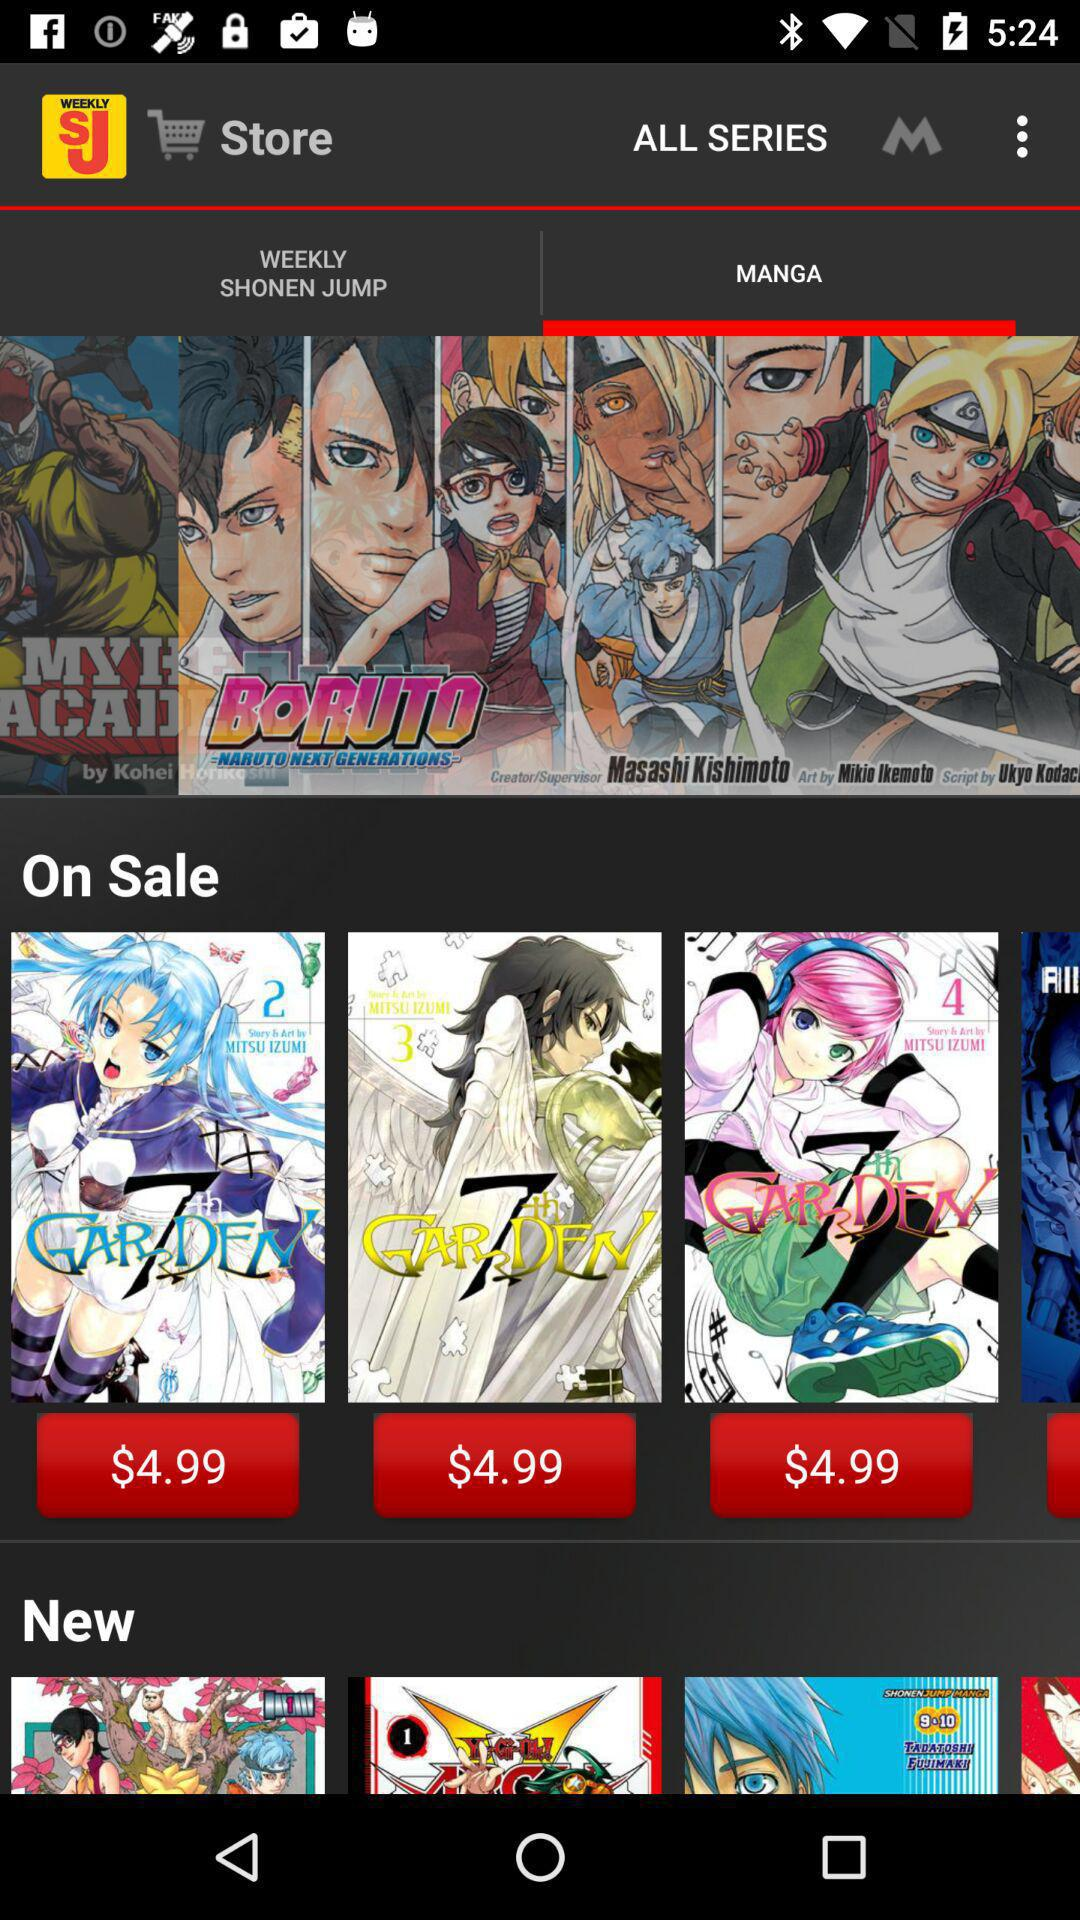How many issues of Weekly Shonen Jump are available?
Answer the question using a single word or phrase. 2 